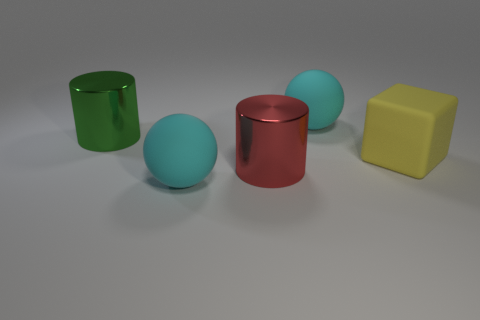Is the number of metal things that are in front of the green thing greater than the number of big brown rubber balls?
Your answer should be compact. Yes. Is there anything else of the same color as the large block?
Provide a short and direct response. No. What is the color of the object that is on the left side of the big matte sphere that is in front of the cyan object that is behind the large yellow rubber object?
Provide a succinct answer. Green. What number of metallic objects have the same size as the yellow matte block?
Your response must be concise. 2. Do the big cyan sphere that is behind the large yellow cube and the big object that is in front of the red cylinder have the same material?
Provide a short and direct response. Yes. Are there any other things that have the same shape as the big yellow rubber object?
Ensure brevity in your answer.  No. The matte block is what color?
Your answer should be very brief. Yellow. How many other big things have the same shape as the big green object?
Make the answer very short. 1. What color is the other metal cylinder that is the same size as the green cylinder?
Keep it short and to the point. Red. Is there a rubber object?
Your response must be concise. Yes. 